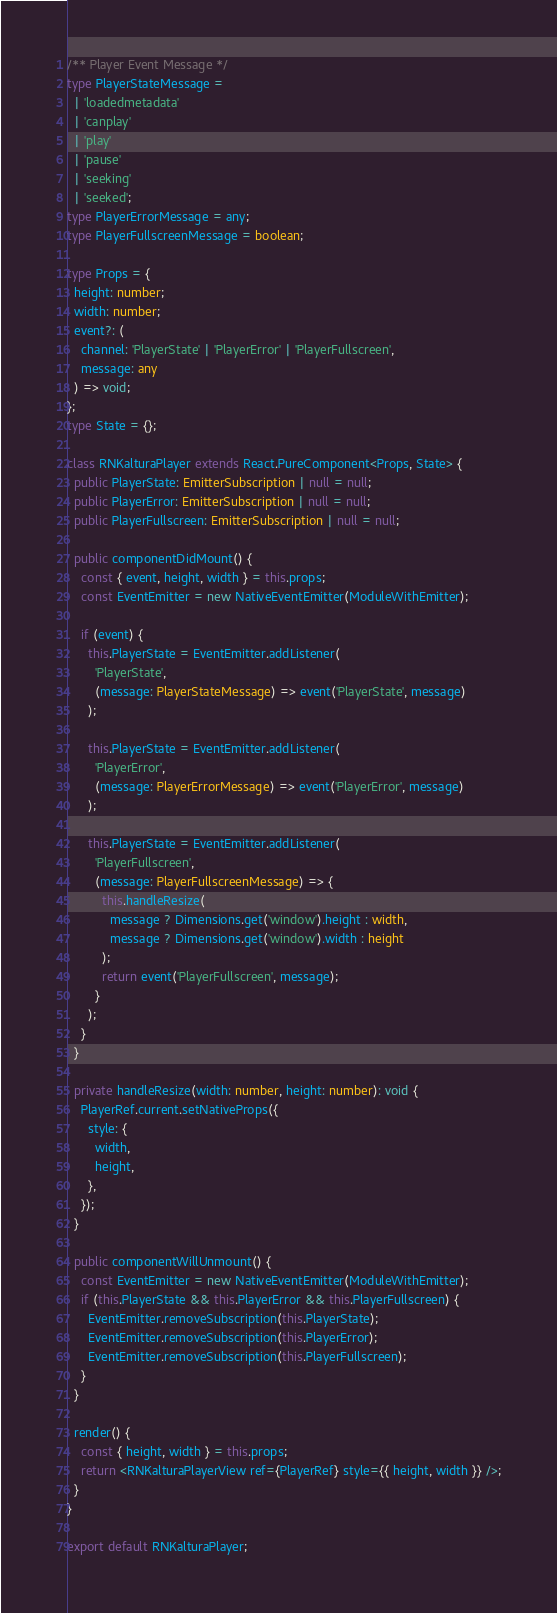<code> <loc_0><loc_0><loc_500><loc_500><_TypeScript_>/** Player Event Message */
type PlayerStateMessage =
  | 'loadedmetadata'
  | 'canplay'
  | 'play'
  | 'pause'
  | 'seeking'
  | 'seeked';
type PlayerErrorMessage = any;
type PlayerFullscreenMessage = boolean;

type Props = {
  height: number;
  width: number;
  event?: (
    channel: 'PlayerState' | 'PlayerError' | 'PlayerFullscreen',
    message: any
  ) => void;
};
type State = {};

class RNKalturaPlayer extends React.PureComponent<Props, State> {
  public PlayerState: EmitterSubscription | null = null;
  public PlayerError: EmitterSubscription | null = null;
  public PlayerFullscreen: EmitterSubscription | null = null;

  public componentDidMount() {
    const { event, height, width } = this.props;
    const EventEmitter = new NativeEventEmitter(ModuleWithEmitter);

    if (event) {
      this.PlayerState = EventEmitter.addListener(
        'PlayerState',
        (message: PlayerStateMessage) => event('PlayerState', message)
      );

      this.PlayerState = EventEmitter.addListener(
        'PlayerError',
        (message: PlayerErrorMessage) => event('PlayerError', message)
      );

      this.PlayerState = EventEmitter.addListener(
        'PlayerFullscreen',
        (message: PlayerFullscreenMessage) => {
          this.handleResize(
            message ? Dimensions.get('window').height : width,
            message ? Dimensions.get('window').width : height
          );
          return event('PlayerFullscreen', message);
        }
      );
    }
  }

  private handleResize(width: number, height: number): void {
    PlayerRef.current.setNativeProps({
      style: {
        width,
        height,
      },
    });
  }

  public componentWillUnmount() {
    const EventEmitter = new NativeEventEmitter(ModuleWithEmitter);
    if (this.PlayerState && this.PlayerError && this.PlayerFullscreen) {
      EventEmitter.removeSubscription(this.PlayerState);
      EventEmitter.removeSubscription(this.PlayerError);
      EventEmitter.removeSubscription(this.PlayerFullscreen);
    }
  }

  render() {
    const { height, width } = this.props;
    return <RNKalturaPlayerView ref={PlayerRef} style={{ height, width }} />;
  }
}

export default RNKalturaPlayer;
</code> 